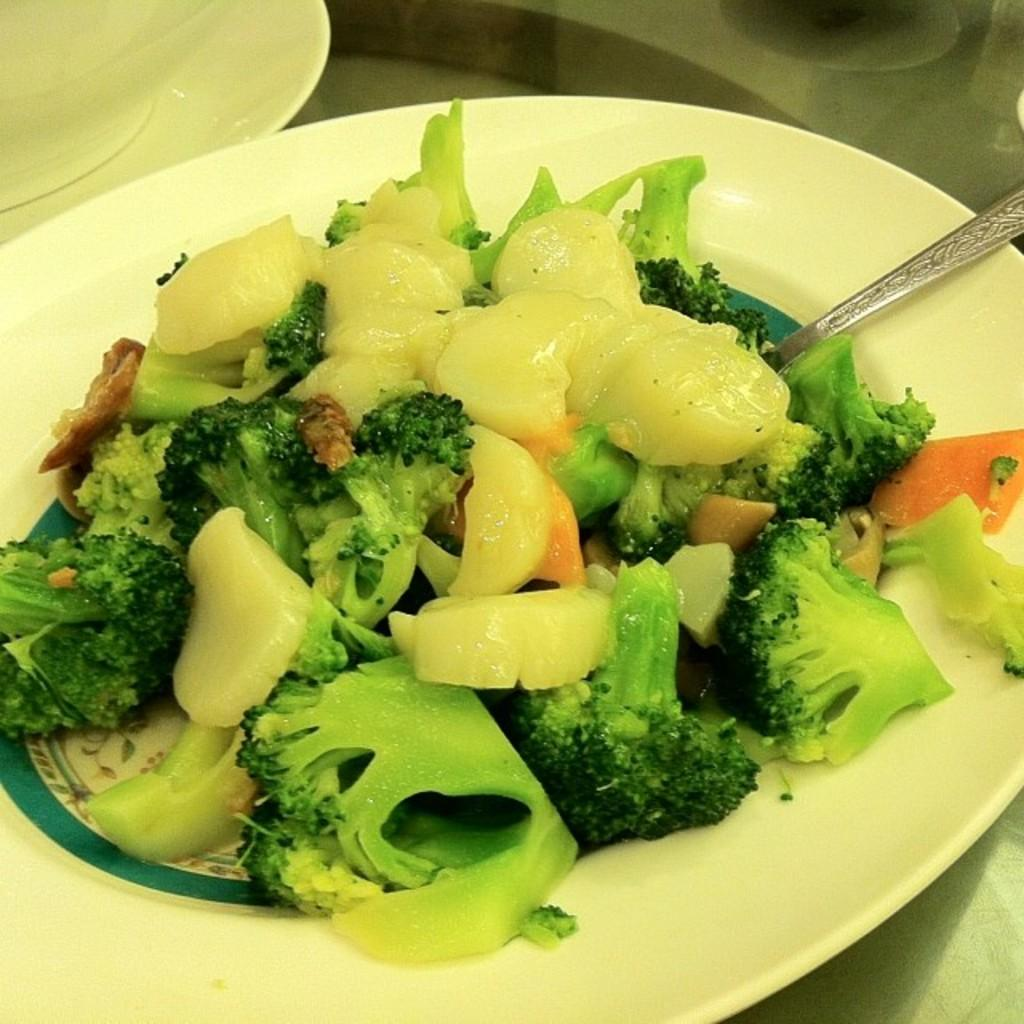How many plates are visible in the image? There are two plates in the image. What is on the plates? There is a food item on the plate. Can you describe the appearance of the food item? The food item has green, orange, and cream colors. What utensil is present on the plate? There is a spoon on the plate. What is the price of the food item on the plate? The price of the food item is not mentioned in the image, so it cannot be determined. 